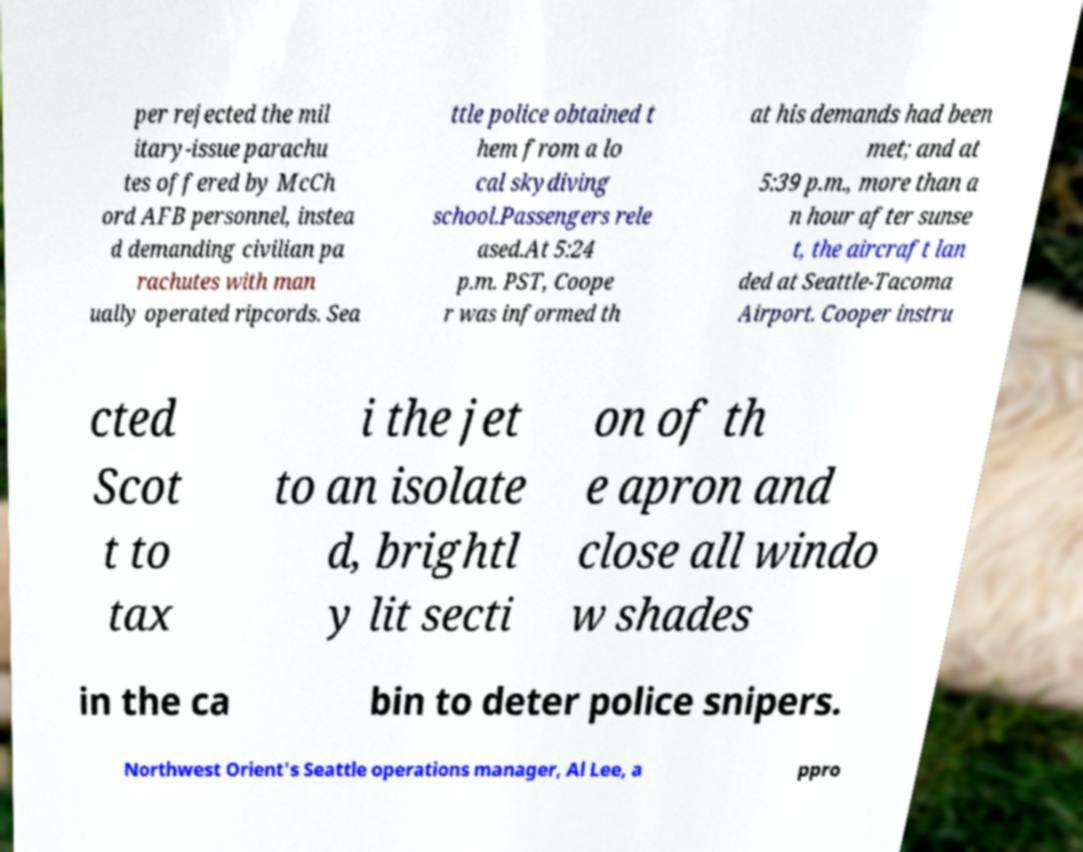Please identify and transcribe the text found in this image. per rejected the mil itary-issue parachu tes offered by McCh ord AFB personnel, instea d demanding civilian pa rachutes with man ually operated ripcords. Sea ttle police obtained t hem from a lo cal skydiving school.Passengers rele ased.At 5:24 p.m. PST, Coope r was informed th at his demands had been met; and at 5:39 p.m., more than a n hour after sunse t, the aircraft lan ded at Seattle-Tacoma Airport. Cooper instru cted Scot t to tax i the jet to an isolate d, brightl y lit secti on of th e apron and close all windo w shades in the ca bin to deter police snipers. Northwest Orient's Seattle operations manager, Al Lee, a ppro 